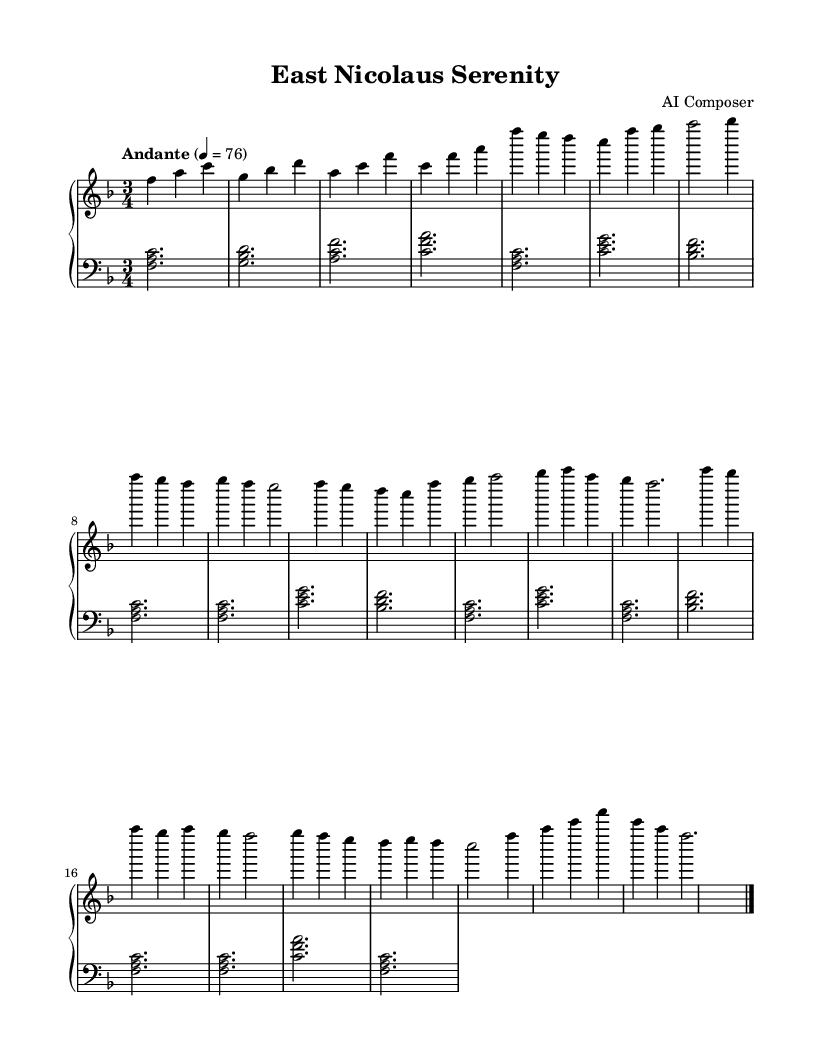What is the key signature of this music? The key signature indicates F major as there are one flat. This is derived from the `\key f \major` command in the code that specifies the key signature in the sheet music.
Answer: F major What is the time signature of this music? The time signature is indicated by the `\time 3/4` command. This notation specifies that there are three beats per measure, with each beat represented by a quarter note.
Answer: 3/4 What is the tempo marking of this piece? The tempo marking is provided in the code with `\tempo "Andante" 4 = 76`. This indicates that the piece should be played at a moderately slow pace.
Answer: Andante How many measures are in the A section of the piece? The A section consists of 8 measures as counted in the right hand part. Each set of notes between the bar lines is counted as one measure.
Answer: 8 What is the overall mood suggested by this composition? The music's use of flowing melodies and a moderate tempo tends to evoke a serene and calming mood. This is supported by the choice of musical phrases that are soothing and reflective.
Answer: Serene What is the first note of the piece? The first note is F, as indicated at the start of the right-hand melody with an F note at the beginning of the first measure.
Answer: F What musical form does this piece follow? The piece follows a ternary form, also known as A-B-A, where the A section is repeated after a contrasting B section. This is determined by the repeated sections in the sheet music layout.
Answer: Ternary 